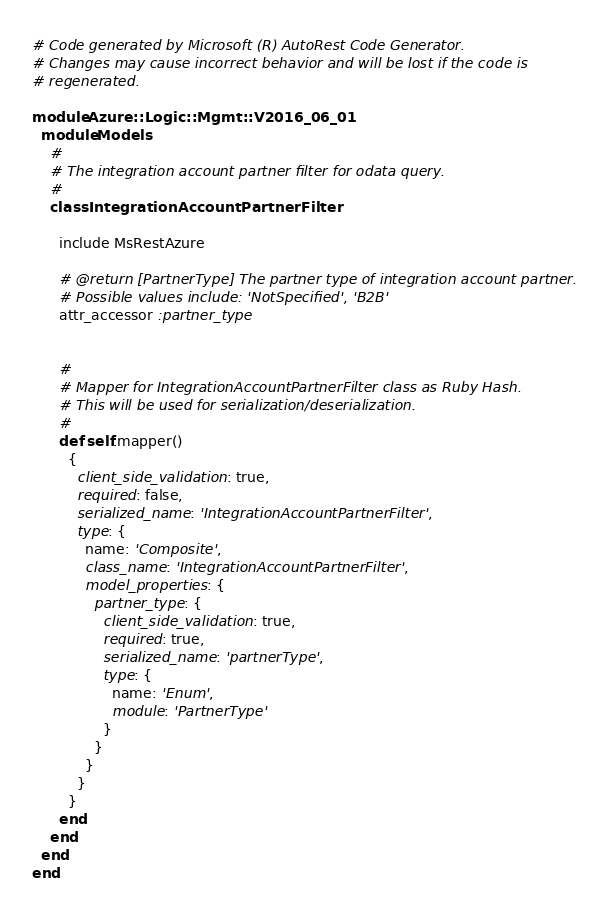<code> <loc_0><loc_0><loc_500><loc_500><_Ruby_># Code generated by Microsoft (R) AutoRest Code Generator.
# Changes may cause incorrect behavior and will be lost if the code is
# regenerated.

module Azure::Logic::Mgmt::V2016_06_01
  module Models
    #
    # The integration account partner filter for odata query.
    #
    class IntegrationAccountPartnerFilter

      include MsRestAzure

      # @return [PartnerType] The partner type of integration account partner.
      # Possible values include: 'NotSpecified', 'B2B'
      attr_accessor :partner_type


      #
      # Mapper for IntegrationAccountPartnerFilter class as Ruby Hash.
      # This will be used for serialization/deserialization.
      #
      def self.mapper()
        {
          client_side_validation: true,
          required: false,
          serialized_name: 'IntegrationAccountPartnerFilter',
          type: {
            name: 'Composite',
            class_name: 'IntegrationAccountPartnerFilter',
            model_properties: {
              partner_type: {
                client_side_validation: true,
                required: true,
                serialized_name: 'partnerType',
                type: {
                  name: 'Enum',
                  module: 'PartnerType'
                }
              }
            }
          }
        }
      end
    end
  end
end
</code> 